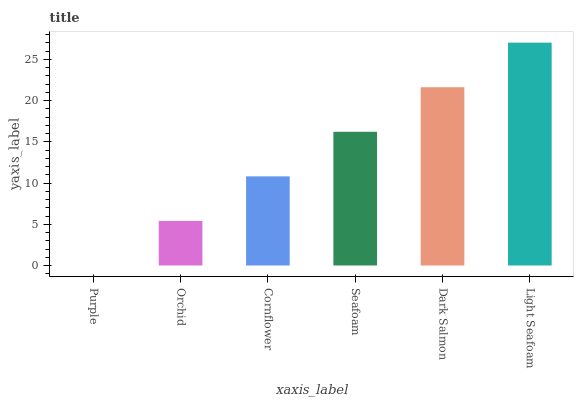Is Orchid the minimum?
Answer yes or no. No. Is Orchid the maximum?
Answer yes or no. No. Is Orchid greater than Purple?
Answer yes or no. Yes. Is Purple less than Orchid?
Answer yes or no. Yes. Is Purple greater than Orchid?
Answer yes or no. No. Is Orchid less than Purple?
Answer yes or no. No. Is Seafoam the high median?
Answer yes or no. Yes. Is Cornflower the low median?
Answer yes or no. Yes. Is Dark Salmon the high median?
Answer yes or no. No. Is Purple the low median?
Answer yes or no. No. 